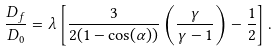<formula> <loc_0><loc_0><loc_500><loc_500>\frac { D _ { f } } { D _ { 0 } } = \lambda \left [ \frac { 3 } { 2 ( 1 - \cos ( \alpha ) ) } \left ( \frac { \gamma } { \gamma - 1 } \right ) - \frac { 1 } { 2 } \right ] .</formula> 